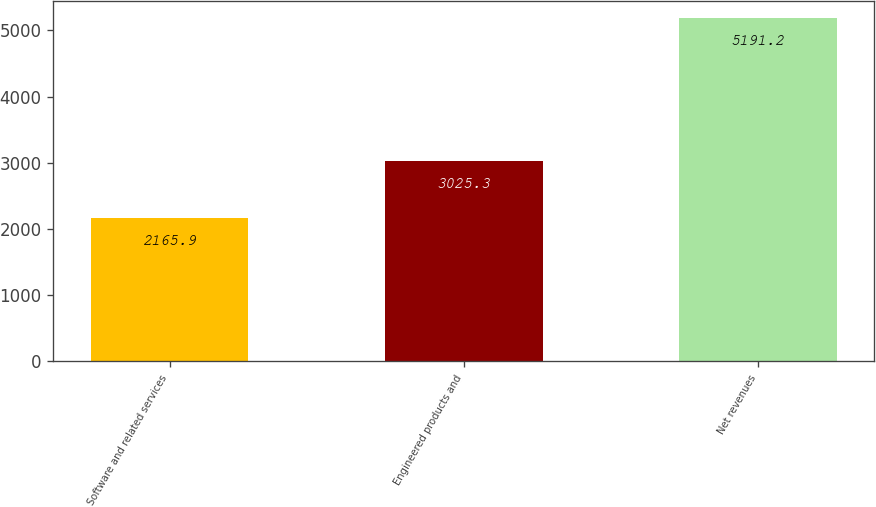Convert chart to OTSL. <chart><loc_0><loc_0><loc_500><loc_500><bar_chart><fcel>Software and related services<fcel>Engineered products and<fcel>Net revenues<nl><fcel>2165.9<fcel>3025.3<fcel>5191.2<nl></chart> 